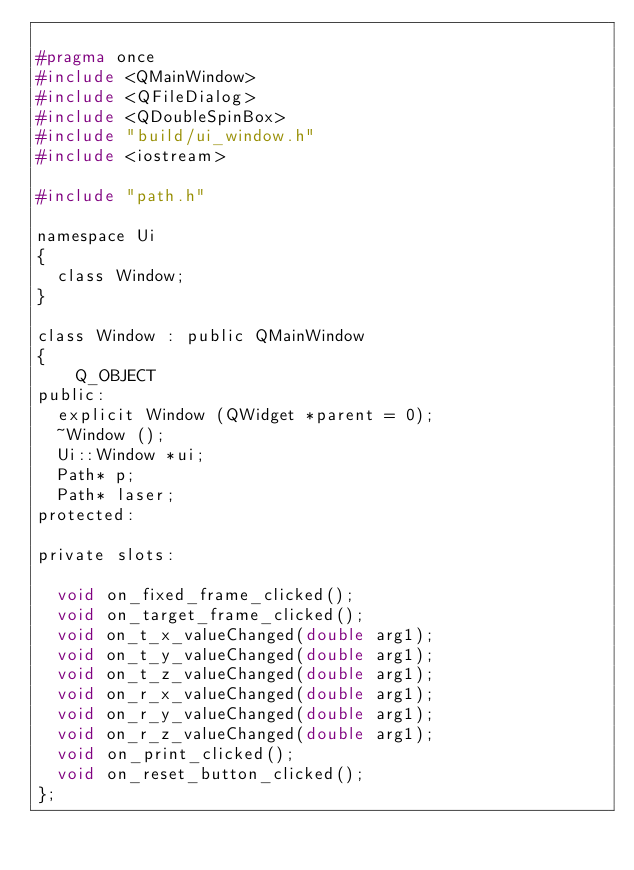<code> <loc_0><loc_0><loc_500><loc_500><_C_>
#pragma once
#include <QMainWindow>
#include <QFileDialog>
#include <QDoubleSpinBox>
#include "build/ui_window.h"
#include <iostream>

#include "path.h"

namespace Ui
{
  class Window;
}

class Window : public QMainWindow
{
    Q_OBJECT
public:
  explicit Window (QWidget *parent = 0);
  ~Window ();
  Ui::Window *ui;
  Path* p;
  Path* laser;
protected:

private slots:  

  void on_fixed_frame_clicked();
  void on_target_frame_clicked();
  void on_t_x_valueChanged(double arg1);
  void on_t_y_valueChanged(double arg1);
  void on_t_z_valueChanged(double arg1);
  void on_r_x_valueChanged(double arg1);
  void on_r_y_valueChanged(double arg1);
  void on_r_z_valueChanged(double arg1);
  void on_print_clicked();
  void on_reset_button_clicked();
};
</code> 